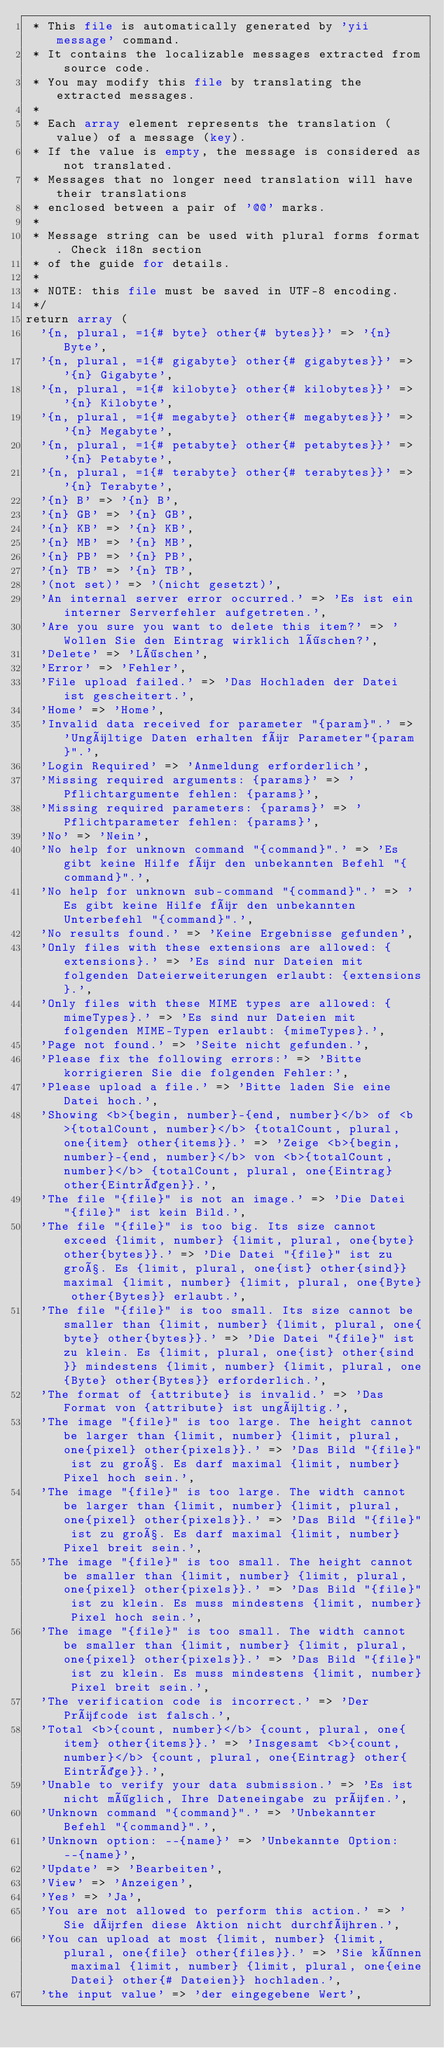<code> <loc_0><loc_0><loc_500><loc_500><_PHP_> * This file is automatically generated by 'yii message' command.
 * It contains the localizable messages extracted from source code.
 * You may modify this file by translating the extracted messages.
 *
 * Each array element represents the translation (value) of a message (key).
 * If the value is empty, the message is considered as not translated.
 * Messages that no longer need translation will have their translations
 * enclosed between a pair of '@@' marks.
 *
 * Message string can be used with plural forms format. Check i18n section
 * of the guide for details.
 *
 * NOTE: this file must be saved in UTF-8 encoding.
 */
return array (
  '{n, plural, =1{# byte} other{# bytes}}' => '{n} Byte',
  '{n, plural, =1{# gigabyte} other{# gigabytes}}' => '{n} Gigabyte',
  '{n, plural, =1{# kilobyte} other{# kilobytes}}' => '{n} Kilobyte',
  '{n, plural, =1{# megabyte} other{# megabytes}}' => '{n} Megabyte',
  '{n, plural, =1{# petabyte} other{# petabytes}}' => '{n} Petabyte',
  '{n, plural, =1{# terabyte} other{# terabytes}}' => '{n} Terabyte',
  '{n} B' => '{n} B',
  '{n} GB' => '{n} GB',
  '{n} KB' => '{n} KB',
  '{n} MB' => '{n} MB',
  '{n} PB' => '{n} PB',
  '{n} TB' => '{n} TB',
  '(not set)' => '(nicht gesetzt)',
  'An internal server error occurred.' => 'Es ist ein interner Serverfehler aufgetreten.',
  'Are you sure you want to delete this item?' => 'Wollen Sie den Eintrag wirklich löschen?',
  'Delete' => 'Löschen',
  'Error' => 'Fehler',
  'File upload failed.' => 'Das Hochladen der Datei ist gescheitert.',
  'Home' => 'Home',
  'Invalid data received for parameter "{param}".' => 'Ungültige Daten erhalten für Parameter"{param}".',
  'Login Required' => 'Anmeldung erforderlich',
  'Missing required arguments: {params}' => 'Pflichtargumente fehlen: {params}',
  'Missing required parameters: {params}' => 'Pflichtparameter fehlen: {params}',
  'No' => 'Nein',
  'No help for unknown command "{command}".' => 'Es gibt keine Hilfe für den unbekannten Befehl "{command}".',
  'No help for unknown sub-command "{command}".' => 'Es gibt keine Hilfe für den unbekannten Unterbefehl "{command}".',
  'No results found.' => 'Keine Ergebnisse gefunden',
  'Only files with these extensions are allowed: {extensions}.' => 'Es sind nur Dateien mit folgenden Dateierweiterungen erlaubt: {extensions}.',
  'Only files with these MIME types are allowed: {mimeTypes}.' => 'Es sind nur Dateien mit folgenden MIME-Typen erlaubt: {mimeTypes}.',
  'Page not found.' => 'Seite nicht gefunden.',
  'Please fix the following errors:' => 'Bitte korrigieren Sie die folgenden Fehler:',
  'Please upload a file.' => 'Bitte laden Sie eine Datei hoch.',
  'Showing <b>{begin, number}-{end, number}</b> of <b>{totalCount, number}</b> {totalCount, plural, one{item} other{items}}.' => 'Zeige <b>{begin, number}-{end, number}</b> von <b>{totalCount, number}</b> {totalCount, plural, one{Eintrag} other{Einträgen}}.',
  'The file "{file}" is not an image.' => 'Die Datei "{file}" ist kein Bild.',
  'The file "{file}" is too big. Its size cannot exceed {limit, number} {limit, plural, one{byte} other{bytes}}.' => 'Die Datei "{file}" ist zu groß. Es {limit, plural, one{ist} other{sind}} maximal {limit, number} {limit, plural, one{Byte} other{Bytes}} erlaubt.',
  'The file "{file}" is too small. Its size cannot be smaller than {limit, number} {limit, plural, one{byte} other{bytes}}.' => 'Die Datei "{file}" ist zu klein. Es {limit, plural, one{ist} other{sind}} mindestens {limit, number} {limit, plural, one{Byte} other{Bytes}} erforderlich.',
  'The format of {attribute} is invalid.' => 'Das Format von {attribute} ist ungültig.',
  'The image "{file}" is too large. The height cannot be larger than {limit, number} {limit, plural, one{pixel} other{pixels}}.' => 'Das Bild "{file}" ist zu groß. Es darf maximal {limit, number} Pixel hoch sein.',
  'The image "{file}" is too large. The width cannot be larger than {limit, number} {limit, plural, one{pixel} other{pixels}}.' => 'Das Bild "{file}" ist zu groß. Es darf maximal {limit, number} Pixel breit sein.',
  'The image "{file}" is too small. The height cannot be smaller than {limit, number} {limit, plural, one{pixel} other{pixels}}.' => 'Das Bild "{file}" ist zu klein. Es muss mindestens {limit, number} Pixel hoch sein.',
  'The image "{file}" is too small. The width cannot be smaller than {limit, number} {limit, plural, one{pixel} other{pixels}}.' => 'Das Bild "{file}" ist zu klein. Es muss mindestens {limit, number} Pixel breit sein.',
  'The verification code is incorrect.' => 'Der Prüfcode ist falsch.',
  'Total <b>{count, number}</b> {count, plural, one{item} other{items}}.' => 'Insgesamt <b>{count, number}</b> {count, plural, one{Eintrag} other{Einträge}}.',
  'Unable to verify your data submission.' => 'Es ist nicht möglich, Ihre Dateneingabe zu prüfen.',
  'Unknown command "{command}".' => 'Unbekannter Befehl "{command}".',
  'Unknown option: --{name}' => 'Unbekannte Option: --{name}',
  'Update' => 'Bearbeiten',
  'View' => 'Anzeigen',
  'Yes' => 'Ja',
  'You are not allowed to perform this action.' => 'Sie dürfen diese Aktion nicht durchführen.',
  'You can upload at most {limit, number} {limit, plural, one{file} other{files}}.' => 'Sie können maximal {limit, number} {limit, plural, one{eine Datei} other{# Dateien}} hochladen.',
  'the input value' => 'der eingegebene Wert',</code> 